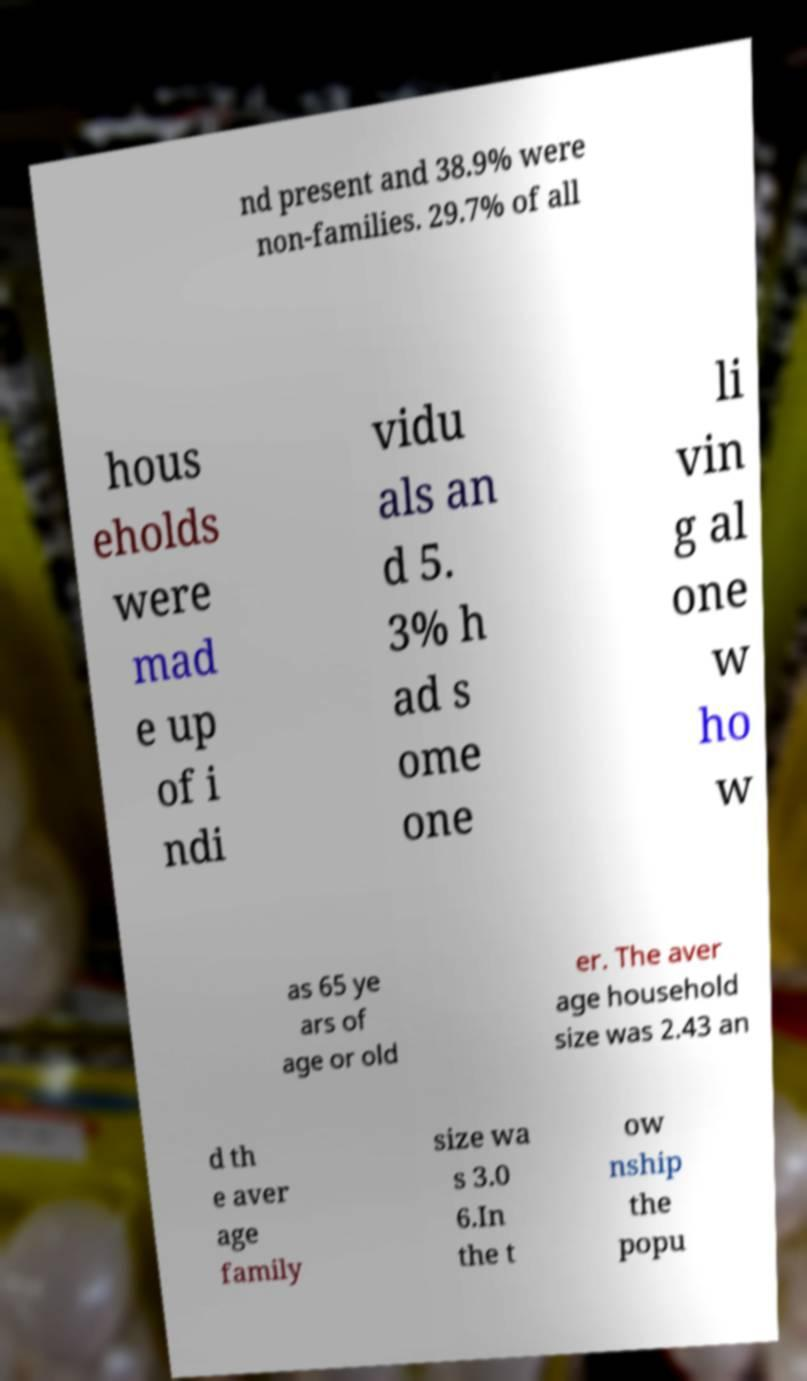For documentation purposes, I need the text within this image transcribed. Could you provide that? nd present and 38.9% were non-families. 29.7% of all hous eholds were mad e up of i ndi vidu als an d 5. 3% h ad s ome one li vin g al one w ho w as 65 ye ars of age or old er. The aver age household size was 2.43 an d th e aver age family size wa s 3.0 6.In the t ow nship the popu 